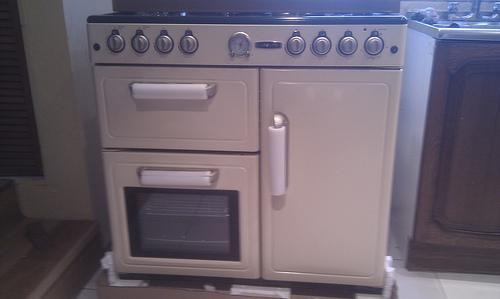How many knobs are on the front of the stove?
Give a very brief answer. 8. 